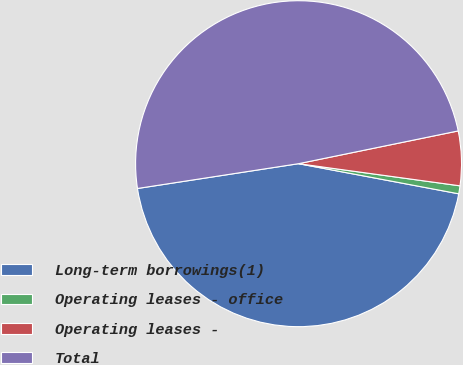Convert chart to OTSL. <chart><loc_0><loc_0><loc_500><loc_500><pie_chart><fcel>Long-term borrowings(1)<fcel>Operating leases - office<fcel>Operating leases -<fcel>Total<nl><fcel>44.61%<fcel>0.79%<fcel>5.39%<fcel>49.21%<nl></chart> 